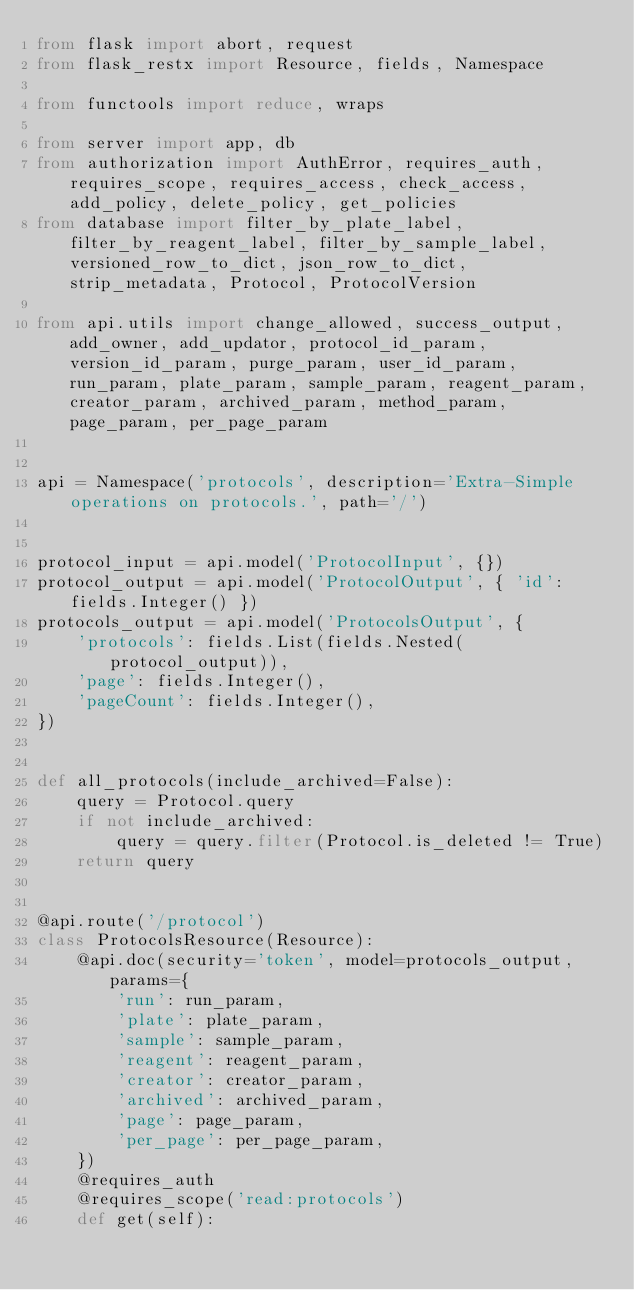<code> <loc_0><loc_0><loc_500><loc_500><_Python_>from flask import abort, request
from flask_restx import Resource, fields, Namespace

from functools import reduce, wraps

from server import app, db
from authorization import AuthError, requires_auth, requires_scope, requires_access, check_access, add_policy, delete_policy, get_policies
from database import filter_by_plate_label, filter_by_reagent_label, filter_by_sample_label, versioned_row_to_dict, json_row_to_dict, strip_metadata, Protocol, ProtocolVersion

from api.utils import change_allowed, success_output, add_owner, add_updator, protocol_id_param, version_id_param, purge_param, user_id_param, run_param, plate_param, sample_param, reagent_param, creator_param, archived_param, method_param, page_param, per_page_param


api = Namespace('protocols', description='Extra-Simple operations on protocols.', path='/')


protocol_input = api.model('ProtocolInput', {})
protocol_output = api.model('ProtocolOutput', { 'id': fields.Integer() })
protocols_output = api.model('ProtocolsOutput', {
    'protocols': fields.List(fields.Nested(protocol_output)),
    'page': fields.Integer(),
    'pageCount': fields.Integer(),
})


def all_protocols(include_archived=False):
    query = Protocol.query
    if not include_archived:
        query = query.filter(Protocol.is_deleted != True)
    return query


@api.route('/protocol')
class ProtocolsResource(Resource):
    @api.doc(security='token', model=protocols_output, params={
        'run': run_param,
        'plate': plate_param,
        'sample': sample_param,
        'reagent': reagent_param,
        'creator': creator_param,
        'archived': archived_param,
        'page': page_param,
        'per_page': per_page_param,
    })
    @requires_auth
    @requires_scope('read:protocols')
    def get(self):</code> 